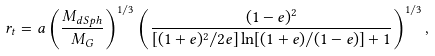<formula> <loc_0><loc_0><loc_500><loc_500>r _ { t } = a \left ( \frac { M _ { d S p h } } { M _ { G } } \right ) ^ { 1 / 3 } \left ( \frac { ( 1 - e ) ^ { 2 } } { [ ( 1 + e ) ^ { 2 } / 2 e ] \ln [ ( 1 + e ) / ( 1 - e ) ] + 1 } \right ) ^ { 1 / 3 } ,</formula> 